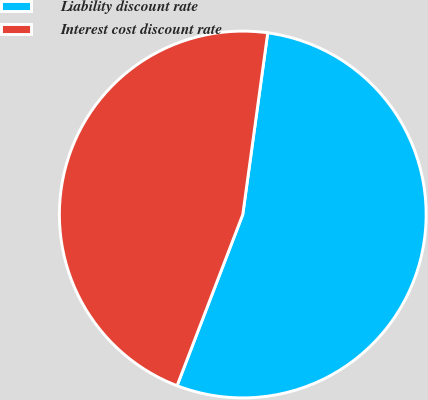Convert chart to OTSL. <chart><loc_0><loc_0><loc_500><loc_500><pie_chart><fcel>Liability discount rate<fcel>Interest cost discount rate<nl><fcel>53.66%<fcel>46.34%<nl></chart> 